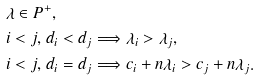<formula> <loc_0><loc_0><loc_500><loc_500>& \lambda \in P ^ { + } , \\ & i < j , \, d _ { i } < d _ { j } \Longrightarrow \lambda _ { i } > \lambda _ { j } , \\ & i < j , \, d _ { i } = d _ { j } \Longrightarrow c _ { i } + n \lambda _ { i } > c _ { j } + n \lambda _ { j } .</formula> 